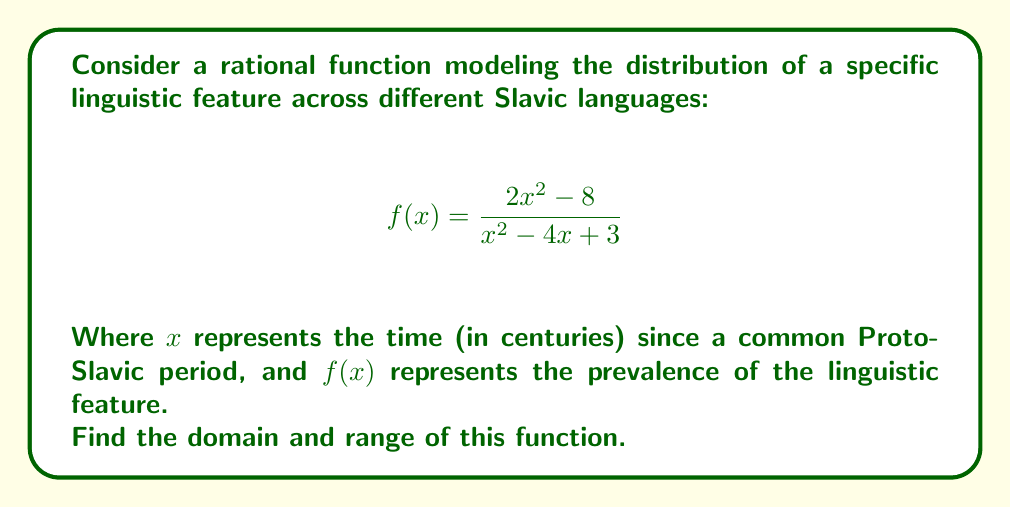Could you help me with this problem? To find the domain and range of this rational function, we'll follow these steps:

1. Domain:
   The domain includes all real numbers except those that make the denominator zero.
   Set the denominator equal to zero and solve:
   $$x^2 - 4x + 3 = 0$$
   $$(x - 1)(x - 3) = 0$$
   $$x = 1 \text{ or } x = 3$$

   Therefore, the domain is all real numbers except 1 and 3.

2. Range:
   To find the range, we'll rewrite the function in the form of $y = f(x)$:
   $$y = \frac{2x^2 - 8}{x^2 - 4x + 3}$$

   Multiply both sides by the denominator:
   $$y(x^2 - 4x + 3) = 2x^2 - 8$$

   Expand:
   $$yx^2 - 4yx + 3y = 2x^2 - 8$$

   Rearrange to standard form:
   $$x^2(y - 2) + x(-4y) + (3y + 8) = 0$$

   For this to be a perfect square trinomial in x, its discriminant must be zero:
   $$(-4y)^2 - 4(y-2)(3y+8) = 0$$
   $$16y^2 - 4(3y^2 + 8y - 6y - 16) = 0$$
   $$16y^2 - 4(3y^2 + 2y - 16) = 0$$
   $$16y^2 - 12y^2 - 8y + 64 = 0$$
   $$4y^2 - 8y + 64 = 0$$
   $$y^2 - 2y + 16 = 0$$
   $$(y - 1)^2 = -15$$

   This equation has no real solutions, which means the parabola never touches the x-axis.
   Therefore, the range is all real numbers except 1.
Answer: Domain: $\{x \in \mathbb{R} : x \neq 1 \text{ and } x \neq 3\}$
Range: $\{y \in \mathbb{R} : y \neq 1\}$ 